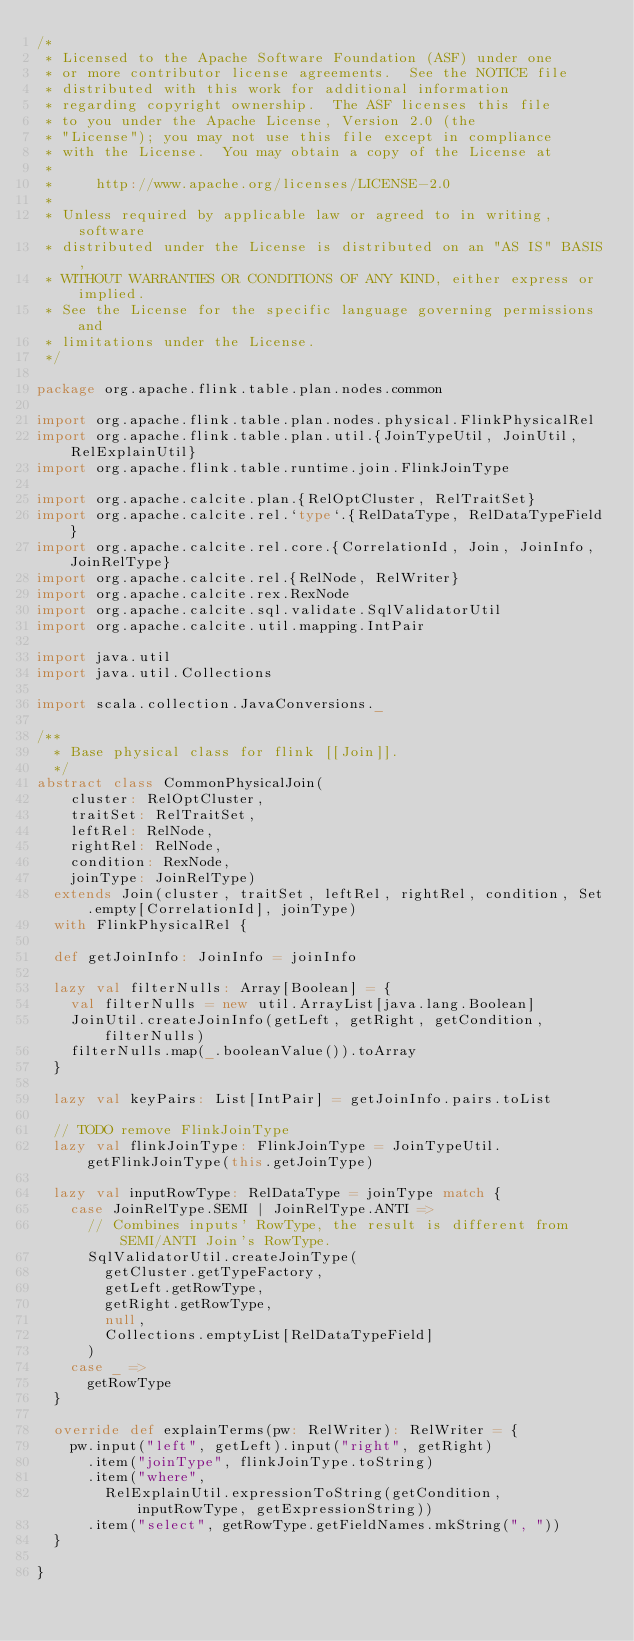<code> <loc_0><loc_0><loc_500><loc_500><_Scala_>/*
 * Licensed to the Apache Software Foundation (ASF) under one
 * or more contributor license agreements.  See the NOTICE file
 * distributed with this work for additional information
 * regarding copyright ownership.  The ASF licenses this file
 * to you under the Apache License, Version 2.0 (the
 * "License"); you may not use this file except in compliance
 * with the License.  You may obtain a copy of the License at
 *
 *     http://www.apache.org/licenses/LICENSE-2.0
 *
 * Unless required by applicable law or agreed to in writing, software
 * distributed under the License is distributed on an "AS IS" BASIS,
 * WITHOUT WARRANTIES OR CONDITIONS OF ANY KIND, either express or implied.
 * See the License for the specific language governing permissions and
 * limitations under the License.
 */

package org.apache.flink.table.plan.nodes.common

import org.apache.flink.table.plan.nodes.physical.FlinkPhysicalRel
import org.apache.flink.table.plan.util.{JoinTypeUtil, JoinUtil, RelExplainUtil}
import org.apache.flink.table.runtime.join.FlinkJoinType

import org.apache.calcite.plan.{RelOptCluster, RelTraitSet}
import org.apache.calcite.rel.`type`.{RelDataType, RelDataTypeField}
import org.apache.calcite.rel.core.{CorrelationId, Join, JoinInfo, JoinRelType}
import org.apache.calcite.rel.{RelNode, RelWriter}
import org.apache.calcite.rex.RexNode
import org.apache.calcite.sql.validate.SqlValidatorUtil
import org.apache.calcite.util.mapping.IntPair

import java.util
import java.util.Collections

import scala.collection.JavaConversions._

/**
  * Base physical class for flink [[Join]].
  */
abstract class CommonPhysicalJoin(
    cluster: RelOptCluster,
    traitSet: RelTraitSet,
    leftRel: RelNode,
    rightRel: RelNode,
    condition: RexNode,
    joinType: JoinRelType)
  extends Join(cluster, traitSet, leftRel, rightRel, condition, Set.empty[CorrelationId], joinType)
  with FlinkPhysicalRel {

  def getJoinInfo: JoinInfo = joinInfo

  lazy val filterNulls: Array[Boolean] = {
    val filterNulls = new util.ArrayList[java.lang.Boolean]
    JoinUtil.createJoinInfo(getLeft, getRight, getCondition, filterNulls)
    filterNulls.map(_.booleanValue()).toArray
  }

  lazy val keyPairs: List[IntPair] = getJoinInfo.pairs.toList

  // TODO remove FlinkJoinType
  lazy val flinkJoinType: FlinkJoinType = JoinTypeUtil.getFlinkJoinType(this.getJoinType)

  lazy val inputRowType: RelDataType = joinType match {
    case JoinRelType.SEMI | JoinRelType.ANTI =>
      // Combines inputs' RowType, the result is different from SEMI/ANTI Join's RowType.
      SqlValidatorUtil.createJoinType(
        getCluster.getTypeFactory,
        getLeft.getRowType,
        getRight.getRowType,
        null,
        Collections.emptyList[RelDataTypeField]
      )
    case _ =>
      getRowType
  }

  override def explainTerms(pw: RelWriter): RelWriter = {
    pw.input("left", getLeft).input("right", getRight)
      .item("joinType", flinkJoinType.toString)
      .item("where",
        RelExplainUtil.expressionToString(getCondition, inputRowType, getExpressionString))
      .item("select", getRowType.getFieldNames.mkString(", "))
  }

}
</code> 